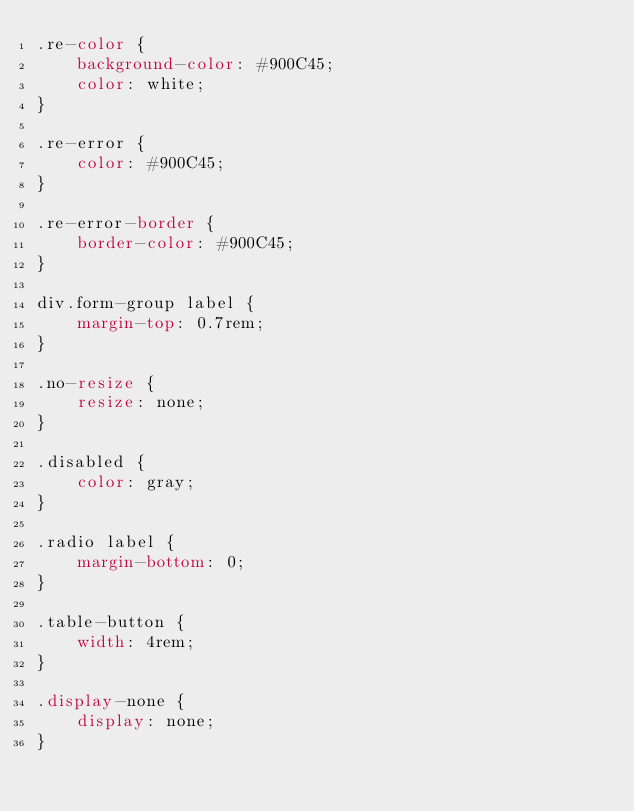<code> <loc_0><loc_0><loc_500><loc_500><_CSS_>.re-color {
    background-color: #900C45;
    color: white;
}

.re-error {
    color: #900C45;
}

.re-error-border {
    border-color: #900C45;
}

div.form-group label {
    margin-top: 0.7rem;
}

.no-resize {
    resize: none;
}

.disabled {
    color: gray;
}

.radio label {
    margin-bottom: 0;
}

.table-button {
    width: 4rem;
}

.display-none {
    display: none;
}
</code> 